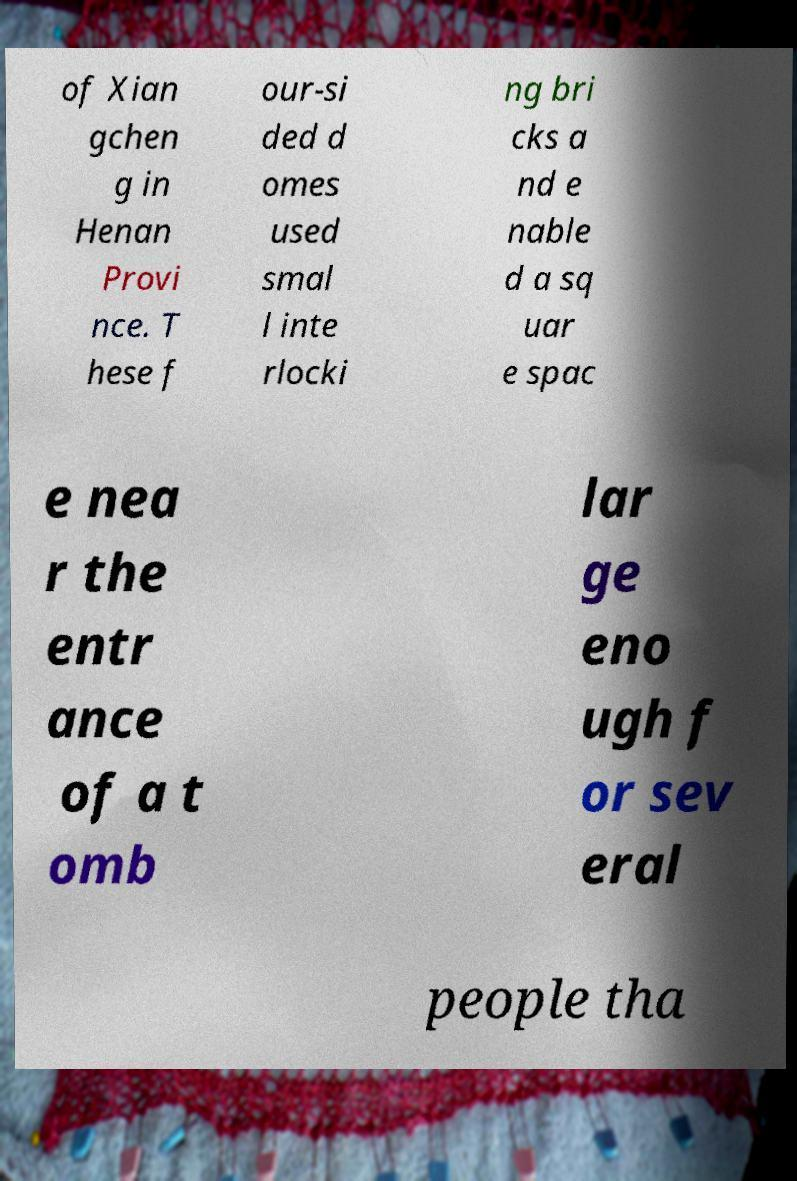Please read and relay the text visible in this image. What does it say? of Xian gchen g in Henan Provi nce. T hese f our-si ded d omes used smal l inte rlocki ng bri cks a nd e nable d a sq uar e spac e nea r the entr ance of a t omb lar ge eno ugh f or sev eral people tha 